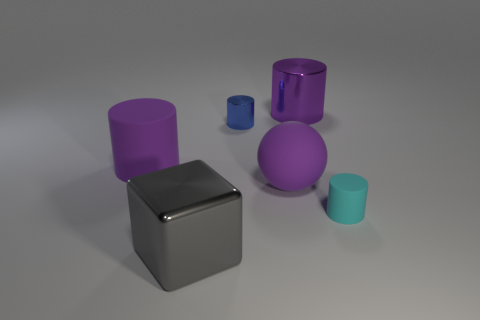Is there anything else that has the same shape as the large gray object?
Make the answer very short. No. Is the tiny cyan cylinder made of the same material as the purple ball?
Ensure brevity in your answer.  Yes. How many other things are there of the same material as the cyan cylinder?
Your answer should be compact. 2. Is the number of tiny blue objects greater than the number of large green matte cubes?
Your response must be concise. Yes. Does the thing that is behind the small metallic object have the same shape as the tiny rubber object?
Your response must be concise. Yes. Are there fewer gray metallic blocks than brown metal cylinders?
Your answer should be compact. No. There is a ball that is the same size as the gray cube; what is it made of?
Keep it short and to the point. Rubber. Do the small metal thing and the big cylinder that is in front of the blue metallic cylinder have the same color?
Ensure brevity in your answer.  No. Are there fewer gray metallic cubes that are left of the large shiny cube than tiny matte things?
Your answer should be compact. Yes. How many cyan objects are there?
Ensure brevity in your answer.  1. 